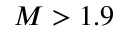Convert formula to latex. <formula><loc_0><loc_0><loc_500><loc_500>M > 1 . 9</formula> 